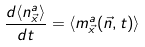Convert formula to latex. <formula><loc_0><loc_0><loc_500><loc_500>\frac { d \langle n _ { \vec { x } } ^ { a } \rangle } { d t } = \langle m _ { \vec { x } } ^ { a } ( \vec { n } , t ) \rangle</formula> 